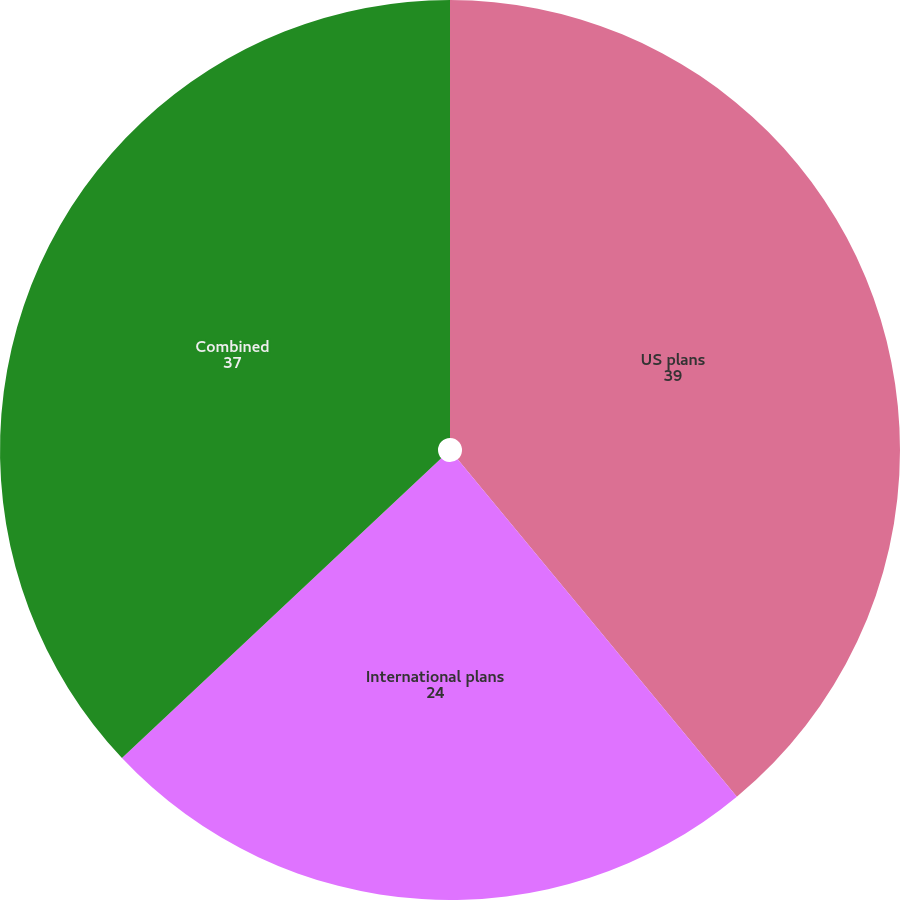Convert chart to OTSL. <chart><loc_0><loc_0><loc_500><loc_500><pie_chart><fcel>US plans<fcel>International plans<fcel>Combined<nl><fcel>39.0%<fcel>24.0%<fcel>37.0%<nl></chart> 